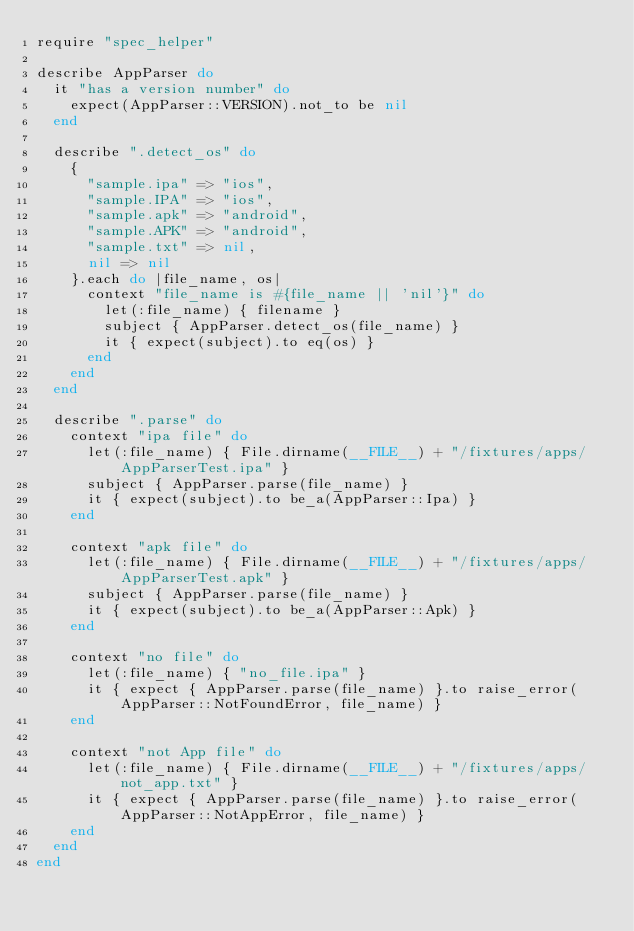Convert code to text. <code><loc_0><loc_0><loc_500><loc_500><_Ruby_>require "spec_helper"

describe AppParser do
  it "has a version number" do
    expect(AppParser::VERSION).not_to be nil
  end

  describe ".detect_os" do
    {
      "sample.ipa" => "ios",
      "sample.IPA" => "ios",
      "sample.apk" => "android",
      "sample.APK" => "android",
      "sample.txt" => nil,
      nil => nil
    }.each do |file_name, os|
      context "file_name is #{file_name || 'nil'}" do
        let(:file_name) { filename }
        subject { AppParser.detect_os(file_name) }
        it { expect(subject).to eq(os) }
      end
    end
  end

  describe ".parse" do
    context "ipa file" do
      let(:file_name) { File.dirname(__FILE__) + "/fixtures/apps/AppParserTest.ipa" }
      subject { AppParser.parse(file_name) }
      it { expect(subject).to be_a(AppParser::Ipa) }
    end

    context "apk file" do
      let(:file_name) { File.dirname(__FILE__) + "/fixtures/apps/AppParserTest.apk" }
      subject { AppParser.parse(file_name) }
      it { expect(subject).to be_a(AppParser::Apk) }
    end

    context "no file" do
      let(:file_name) { "no_file.ipa" }
      it { expect { AppParser.parse(file_name) }.to raise_error(AppParser::NotFoundError, file_name) }
    end

    context "not App file" do
      let(:file_name) { File.dirname(__FILE__) + "/fixtures/apps/not_app.txt" }
      it { expect { AppParser.parse(file_name) }.to raise_error(AppParser::NotAppError, file_name) }
    end
  end
end
</code> 